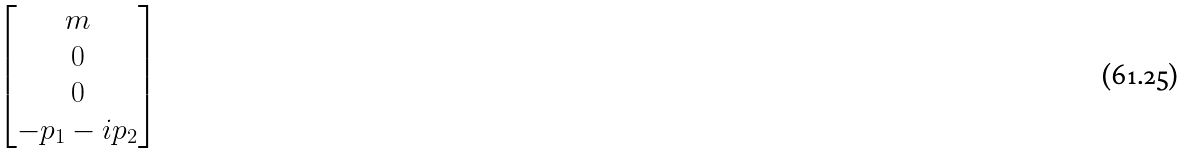Convert formula to latex. <formula><loc_0><loc_0><loc_500><loc_500>\begin{bmatrix} m \\ 0 \\ 0 \\ - p _ { 1 } - i p _ { 2 } \end{bmatrix}</formula> 